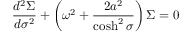Convert formula to latex. <formula><loc_0><loc_0><loc_500><loc_500>\frac { d ^ { 2 } \Sigma } { d \sigma ^ { 2 } } + \left ( { \omega } ^ { 2 } + \frac { 2 a ^ { 2 } } { \cosh ^ { 2 } \sigma } \right ) \Sigma = 0</formula> 